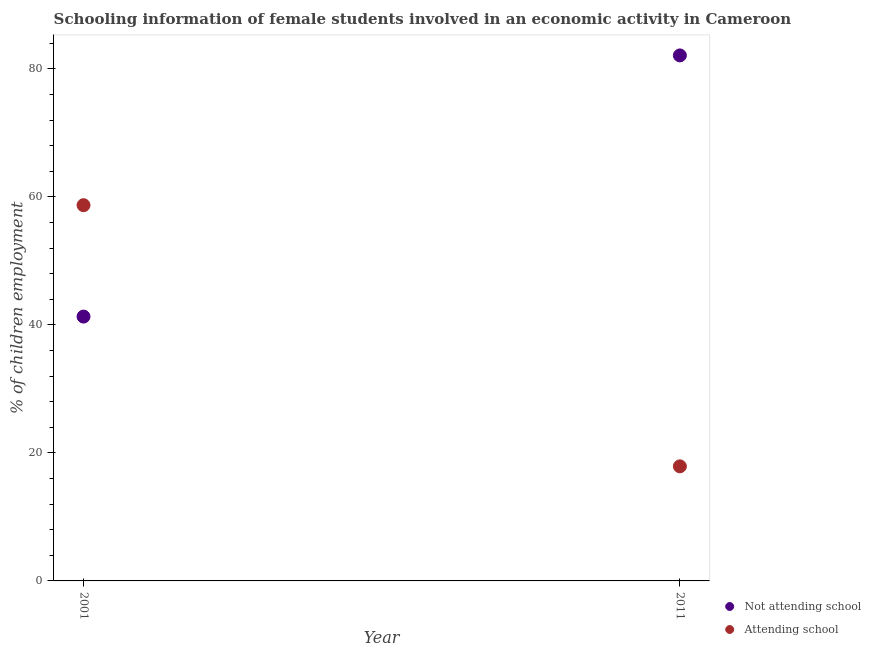What is the percentage of employed females who are attending school in 2001?
Keep it short and to the point. 58.7. Across all years, what is the maximum percentage of employed females who are attending school?
Provide a succinct answer. 58.7. Across all years, what is the minimum percentage of employed females who are attending school?
Your answer should be very brief. 17.9. In which year was the percentage of employed females who are attending school minimum?
Provide a succinct answer. 2011. What is the total percentage of employed females who are attending school in the graph?
Keep it short and to the point. 76.6. What is the difference between the percentage of employed females who are attending school in 2001 and that in 2011?
Ensure brevity in your answer.  40.8. What is the difference between the percentage of employed females who are attending school in 2011 and the percentage of employed females who are not attending school in 2001?
Ensure brevity in your answer.  -23.4. What is the average percentage of employed females who are not attending school per year?
Your response must be concise. 61.7. In the year 2011, what is the difference between the percentage of employed females who are not attending school and percentage of employed females who are attending school?
Ensure brevity in your answer.  64.2. In how many years, is the percentage of employed females who are attending school greater than 60 %?
Your answer should be very brief. 0. What is the ratio of the percentage of employed females who are not attending school in 2001 to that in 2011?
Keep it short and to the point. 0.5. Is the percentage of employed females who are attending school in 2001 less than that in 2011?
Provide a short and direct response. No. In how many years, is the percentage of employed females who are attending school greater than the average percentage of employed females who are attending school taken over all years?
Give a very brief answer. 1. Does the percentage of employed females who are not attending school monotonically increase over the years?
Your response must be concise. Yes. What is the difference between two consecutive major ticks on the Y-axis?
Make the answer very short. 20. Are the values on the major ticks of Y-axis written in scientific E-notation?
Your answer should be very brief. No. Does the graph contain any zero values?
Your answer should be very brief. No. Does the graph contain grids?
Make the answer very short. No. Where does the legend appear in the graph?
Your answer should be very brief. Bottom right. How are the legend labels stacked?
Your answer should be compact. Vertical. What is the title of the graph?
Offer a terse response. Schooling information of female students involved in an economic activity in Cameroon. What is the label or title of the X-axis?
Your answer should be very brief. Year. What is the label or title of the Y-axis?
Offer a very short reply. % of children employment. What is the % of children employment in Not attending school in 2001?
Offer a very short reply. 41.3. What is the % of children employment in Attending school in 2001?
Your response must be concise. 58.7. What is the % of children employment in Not attending school in 2011?
Your answer should be very brief. 82.1. What is the % of children employment of Attending school in 2011?
Your answer should be very brief. 17.9. Across all years, what is the maximum % of children employment of Not attending school?
Make the answer very short. 82.1. Across all years, what is the maximum % of children employment of Attending school?
Offer a terse response. 58.7. Across all years, what is the minimum % of children employment of Not attending school?
Provide a short and direct response. 41.3. Across all years, what is the minimum % of children employment of Attending school?
Keep it short and to the point. 17.9. What is the total % of children employment of Not attending school in the graph?
Ensure brevity in your answer.  123.4. What is the total % of children employment in Attending school in the graph?
Make the answer very short. 76.6. What is the difference between the % of children employment of Not attending school in 2001 and that in 2011?
Offer a terse response. -40.8. What is the difference between the % of children employment in Attending school in 2001 and that in 2011?
Keep it short and to the point. 40.8. What is the difference between the % of children employment in Not attending school in 2001 and the % of children employment in Attending school in 2011?
Provide a short and direct response. 23.4. What is the average % of children employment in Not attending school per year?
Provide a short and direct response. 61.7. What is the average % of children employment in Attending school per year?
Offer a very short reply. 38.3. In the year 2001, what is the difference between the % of children employment in Not attending school and % of children employment in Attending school?
Make the answer very short. -17.41. In the year 2011, what is the difference between the % of children employment of Not attending school and % of children employment of Attending school?
Provide a short and direct response. 64.2. What is the ratio of the % of children employment in Not attending school in 2001 to that in 2011?
Give a very brief answer. 0.5. What is the ratio of the % of children employment in Attending school in 2001 to that in 2011?
Offer a very short reply. 3.28. What is the difference between the highest and the second highest % of children employment in Not attending school?
Provide a succinct answer. 40.8. What is the difference between the highest and the second highest % of children employment of Attending school?
Ensure brevity in your answer.  40.8. What is the difference between the highest and the lowest % of children employment in Not attending school?
Provide a succinct answer. 40.8. What is the difference between the highest and the lowest % of children employment of Attending school?
Provide a succinct answer. 40.8. 